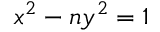<formula> <loc_0><loc_0><loc_500><loc_500>x ^ { 2 } - n y ^ { 2 } = 1</formula> 